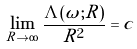<formula> <loc_0><loc_0><loc_500><loc_500>\underset { R \to \infty } { \lim } \, \frac { \Lambda ( \omega ; R ) } { R ^ { 2 } } = c</formula> 